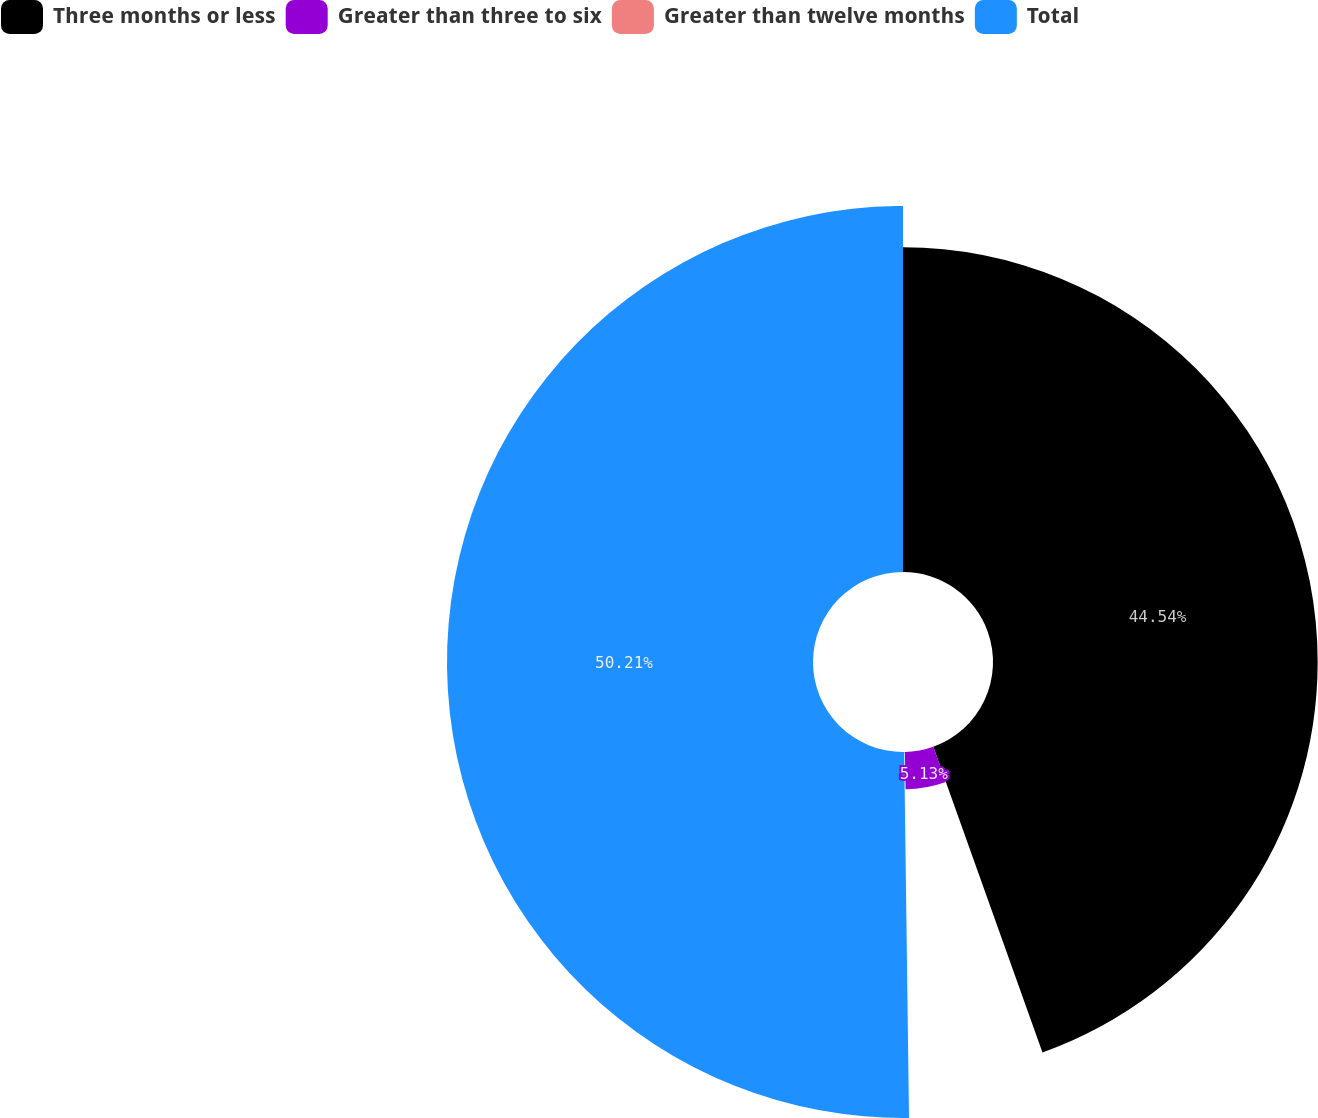<chart> <loc_0><loc_0><loc_500><loc_500><pie_chart><fcel>Three months or less<fcel>Greater than three to six<fcel>Greater than twelve months<fcel>Total<nl><fcel>44.54%<fcel>5.13%<fcel>0.12%<fcel>50.21%<nl></chart> 